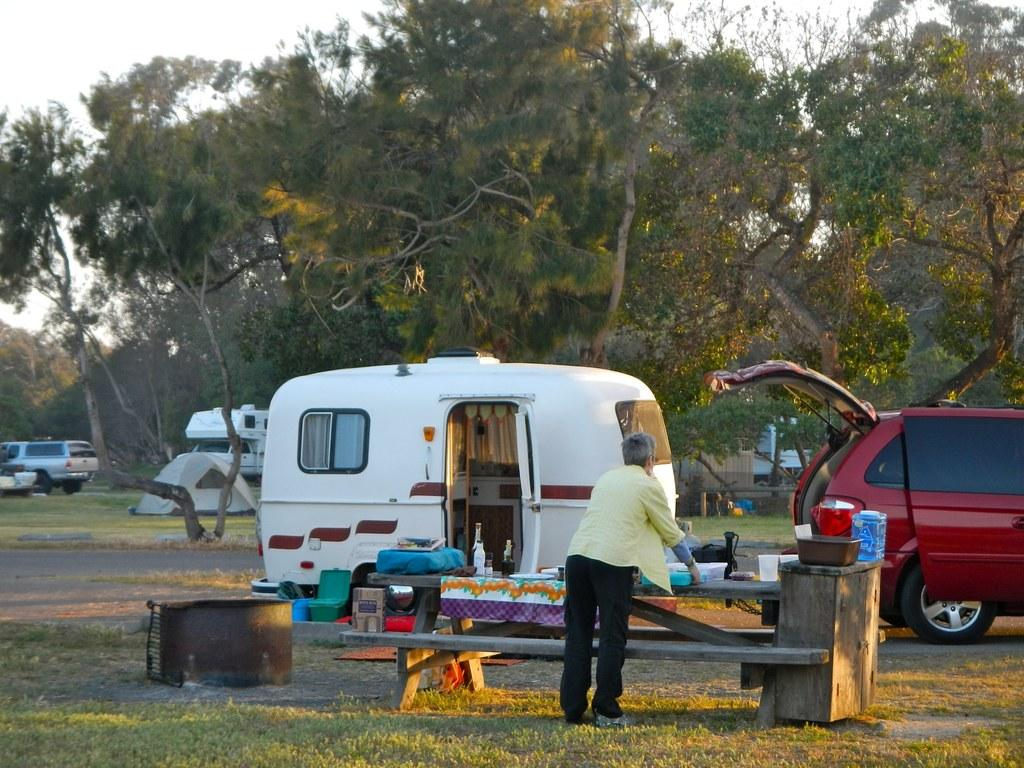What type of furniture is present in the image? There is a table and a bench in the image. Is there a person in the image? Yes, there is a person in the image. What is on the table in the image? There is a container, bottles, and other things on the table. What can be seen in the distance in the image? There is a tent in the distance. What is visible in the background of the image? There are vehicles and trees in the background. What type of machine is being used by the person in the image? There is no machine visible in the image; the person is not using any machine. What is the title of the image? The image does not have a title, as it is not a piece of artwork or literature. 